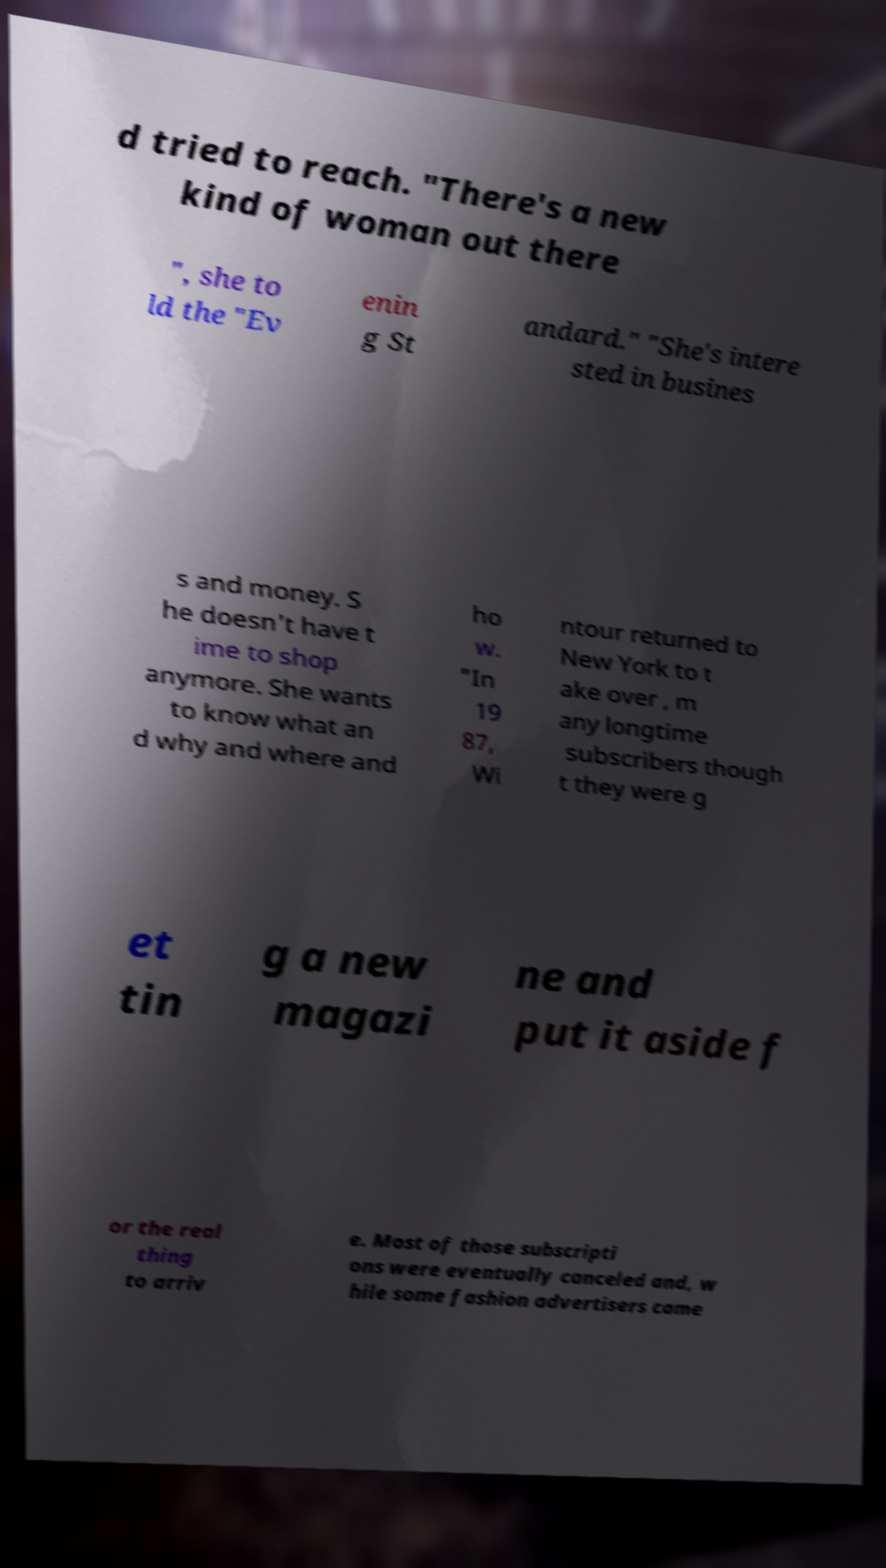Could you extract and type out the text from this image? d tried to reach. "There's a new kind of woman out there ", she to ld the "Ev enin g St andard." "She's intere sted in busines s and money. S he doesn't have t ime to shop anymore. She wants to know what an d why and where and ho w. "In 19 87, Wi ntour returned to New York to t ake over , m any longtime subscribers though t they were g et tin g a new magazi ne and put it aside f or the real thing to arriv e. Most of those subscripti ons were eventually canceled and, w hile some fashion advertisers came 